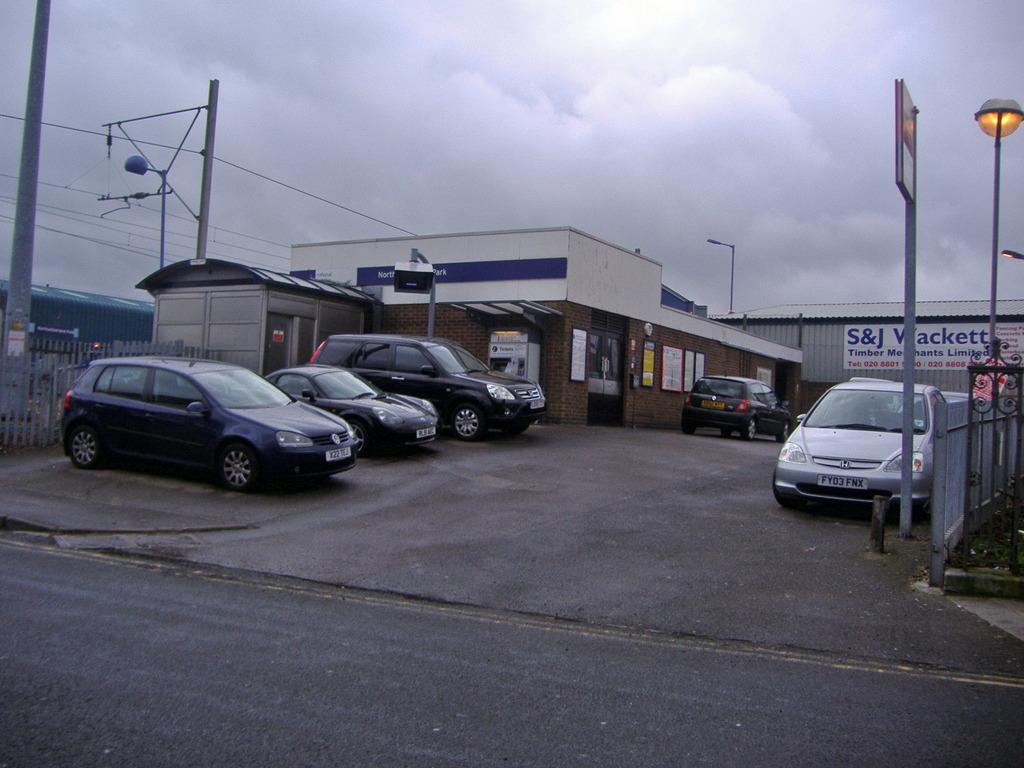Can you describe this image briefly? In this image, we can see cars on the road and in the background, there are sheds, lights, poles along with wires. At the top, there is sky. 